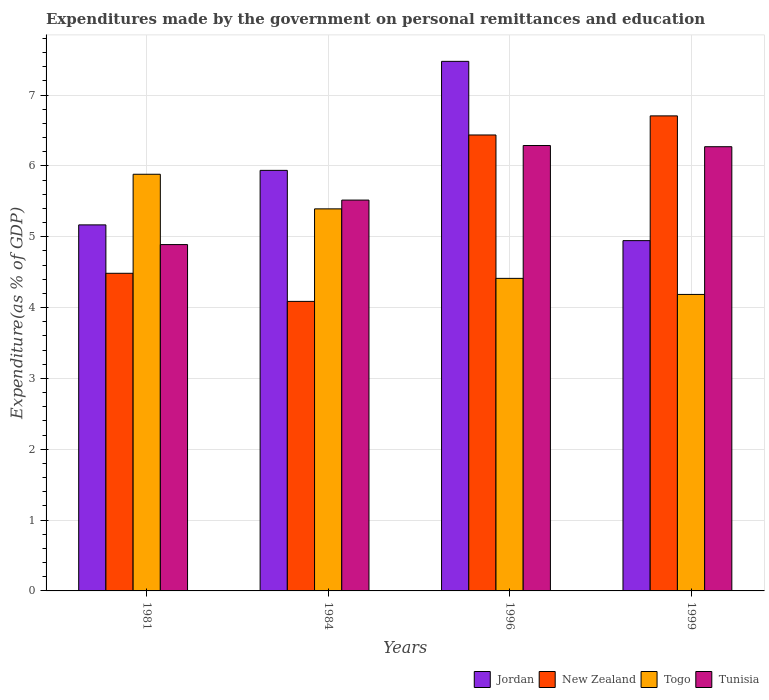How many different coloured bars are there?
Offer a very short reply. 4. How many groups of bars are there?
Make the answer very short. 4. Are the number of bars per tick equal to the number of legend labels?
Ensure brevity in your answer.  Yes. Are the number of bars on each tick of the X-axis equal?
Offer a very short reply. Yes. How many bars are there on the 3rd tick from the left?
Ensure brevity in your answer.  4. How many bars are there on the 1st tick from the right?
Offer a very short reply. 4. What is the expenditures made by the government on personal remittances and education in Jordan in 1984?
Make the answer very short. 5.94. Across all years, what is the maximum expenditures made by the government on personal remittances and education in New Zealand?
Your answer should be very brief. 6.71. Across all years, what is the minimum expenditures made by the government on personal remittances and education in New Zealand?
Ensure brevity in your answer.  4.09. In which year was the expenditures made by the government on personal remittances and education in New Zealand maximum?
Your answer should be compact. 1999. In which year was the expenditures made by the government on personal remittances and education in Jordan minimum?
Offer a terse response. 1999. What is the total expenditures made by the government on personal remittances and education in Jordan in the graph?
Your answer should be very brief. 23.53. What is the difference between the expenditures made by the government on personal remittances and education in Jordan in 1981 and that in 1984?
Offer a terse response. -0.77. What is the difference between the expenditures made by the government on personal remittances and education in Jordan in 1981 and the expenditures made by the government on personal remittances and education in Togo in 1996?
Make the answer very short. 0.75. What is the average expenditures made by the government on personal remittances and education in Jordan per year?
Your response must be concise. 5.88. In the year 1984, what is the difference between the expenditures made by the government on personal remittances and education in Tunisia and expenditures made by the government on personal remittances and education in Jordan?
Provide a succinct answer. -0.42. In how many years, is the expenditures made by the government on personal remittances and education in Togo greater than 1.8 %?
Your response must be concise. 4. What is the ratio of the expenditures made by the government on personal remittances and education in Jordan in 1981 to that in 1996?
Give a very brief answer. 0.69. Is the difference between the expenditures made by the government on personal remittances and education in Tunisia in 1981 and 1996 greater than the difference between the expenditures made by the government on personal remittances and education in Jordan in 1981 and 1996?
Give a very brief answer. Yes. What is the difference between the highest and the second highest expenditures made by the government on personal remittances and education in New Zealand?
Offer a terse response. 0.27. What is the difference between the highest and the lowest expenditures made by the government on personal remittances and education in New Zealand?
Offer a very short reply. 2.62. In how many years, is the expenditures made by the government on personal remittances and education in New Zealand greater than the average expenditures made by the government on personal remittances and education in New Zealand taken over all years?
Your answer should be compact. 2. What does the 1st bar from the left in 1984 represents?
Give a very brief answer. Jordan. What does the 4th bar from the right in 1984 represents?
Make the answer very short. Jordan. What is the difference between two consecutive major ticks on the Y-axis?
Make the answer very short. 1. Does the graph contain any zero values?
Your answer should be very brief. No. Does the graph contain grids?
Provide a succinct answer. Yes. How many legend labels are there?
Offer a very short reply. 4. What is the title of the graph?
Offer a very short reply. Expenditures made by the government on personal remittances and education. Does "OECD members" appear as one of the legend labels in the graph?
Your answer should be very brief. No. What is the label or title of the X-axis?
Provide a short and direct response. Years. What is the label or title of the Y-axis?
Provide a succinct answer. Expenditure(as % of GDP). What is the Expenditure(as % of GDP) in Jordan in 1981?
Your response must be concise. 5.17. What is the Expenditure(as % of GDP) in New Zealand in 1981?
Your response must be concise. 4.48. What is the Expenditure(as % of GDP) of Togo in 1981?
Offer a terse response. 5.88. What is the Expenditure(as % of GDP) in Tunisia in 1981?
Make the answer very short. 4.89. What is the Expenditure(as % of GDP) in Jordan in 1984?
Your answer should be compact. 5.94. What is the Expenditure(as % of GDP) of New Zealand in 1984?
Give a very brief answer. 4.09. What is the Expenditure(as % of GDP) of Togo in 1984?
Ensure brevity in your answer.  5.39. What is the Expenditure(as % of GDP) of Tunisia in 1984?
Offer a terse response. 5.52. What is the Expenditure(as % of GDP) of Jordan in 1996?
Your answer should be very brief. 7.48. What is the Expenditure(as % of GDP) of New Zealand in 1996?
Offer a terse response. 6.44. What is the Expenditure(as % of GDP) in Togo in 1996?
Offer a very short reply. 4.41. What is the Expenditure(as % of GDP) of Tunisia in 1996?
Offer a terse response. 6.29. What is the Expenditure(as % of GDP) of Jordan in 1999?
Your response must be concise. 4.95. What is the Expenditure(as % of GDP) of New Zealand in 1999?
Keep it short and to the point. 6.71. What is the Expenditure(as % of GDP) of Togo in 1999?
Keep it short and to the point. 4.19. What is the Expenditure(as % of GDP) in Tunisia in 1999?
Keep it short and to the point. 6.27. Across all years, what is the maximum Expenditure(as % of GDP) in Jordan?
Provide a short and direct response. 7.48. Across all years, what is the maximum Expenditure(as % of GDP) in New Zealand?
Ensure brevity in your answer.  6.71. Across all years, what is the maximum Expenditure(as % of GDP) of Togo?
Make the answer very short. 5.88. Across all years, what is the maximum Expenditure(as % of GDP) in Tunisia?
Provide a succinct answer. 6.29. Across all years, what is the minimum Expenditure(as % of GDP) in Jordan?
Provide a short and direct response. 4.95. Across all years, what is the minimum Expenditure(as % of GDP) of New Zealand?
Your answer should be very brief. 4.09. Across all years, what is the minimum Expenditure(as % of GDP) in Togo?
Offer a very short reply. 4.19. Across all years, what is the minimum Expenditure(as % of GDP) in Tunisia?
Offer a very short reply. 4.89. What is the total Expenditure(as % of GDP) in Jordan in the graph?
Keep it short and to the point. 23.53. What is the total Expenditure(as % of GDP) of New Zealand in the graph?
Your response must be concise. 21.71. What is the total Expenditure(as % of GDP) of Togo in the graph?
Make the answer very short. 19.87. What is the total Expenditure(as % of GDP) in Tunisia in the graph?
Provide a succinct answer. 22.97. What is the difference between the Expenditure(as % of GDP) in Jordan in 1981 and that in 1984?
Offer a very short reply. -0.77. What is the difference between the Expenditure(as % of GDP) of New Zealand in 1981 and that in 1984?
Your response must be concise. 0.4. What is the difference between the Expenditure(as % of GDP) in Togo in 1981 and that in 1984?
Your response must be concise. 0.49. What is the difference between the Expenditure(as % of GDP) of Tunisia in 1981 and that in 1984?
Provide a succinct answer. -0.63. What is the difference between the Expenditure(as % of GDP) in Jordan in 1981 and that in 1996?
Make the answer very short. -2.31. What is the difference between the Expenditure(as % of GDP) in New Zealand in 1981 and that in 1996?
Your response must be concise. -1.95. What is the difference between the Expenditure(as % of GDP) in Togo in 1981 and that in 1996?
Ensure brevity in your answer.  1.47. What is the difference between the Expenditure(as % of GDP) of Tunisia in 1981 and that in 1996?
Provide a succinct answer. -1.4. What is the difference between the Expenditure(as % of GDP) in Jordan in 1981 and that in 1999?
Make the answer very short. 0.22. What is the difference between the Expenditure(as % of GDP) of New Zealand in 1981 and that in 1999?
Provide a succinct answer. -2.22. What is the difference between the Expenditure(as % of GDP) in Togo in 1981 and that in 1999?
Ensure brevity in your answer.  1.7. What is the difference between the Expenditure(as % of GDP) in Tunisia in 1981 and that in 1999?
Your response must be concise. -1.38. What is the difference between the Expenditure(as % of GDP) in Jordan in 1984 and that in 1996?
Offer a terse response. -1.54. What is the difference between the Expenditure(as % of GDP) in New Zealand in 1984 and that in 1996?
Offer a terse response. -2.35. What is the difference between the Expenditure(as % of GDP) of Togo in 1984 and that in 1996?
Provide a short and direct response. 0.98. What is the difference between the Expenditure(as % of GDP) in Tunisia in 1984 and that in 1996?
Give a very brief answer. -0.77. What is the difference between the Expenditure(as % of GDP) of New Zealand in 1984 and that in 1999?
Offer a terse response. -2.62. What is the difference between the Expenditure(as % of GDP) of Togo in 1984 and that in 1999?
Your answer should be compact. 1.21. What is the difference between the Expenditure(as % of GDP) of Tunisia in 1984 and that in 1999?
Ensure brevity in your answer.  -0.75. What is the difference between the Expenditure(as % of GDP) of Jordan in 1996 and that in 1999?
Make the answer very short. 2.53. What is the difference between the Expenditure(as % of GDP) in New Zealand in 1996 and that in 1999?
Your answer should be very brief. -0.27. What is the difference between the Expenditure(as % of GDP) in Togo in 1996 and that in 1999?
Give a very brief answer. 0.23. What is the difference between the Expenditure(as % of GDP) in Tunisia in 1996 and that in 1999?
Offer a very short reply. 0.02. What is the difference between the Expenditure(as % of GDP) in Jordan in 1981 and the Expenditure(as % of GDP) in Togo in 1984?
Your response must be concise. -0.23. What is the difference between the Expenditure(as % of GDP) in Jordan in 1981 and the Expenditure(as % of GDP) in Tunisia in 1984?
Ensure brevity in your answer.  -0.35. What is the difference between the Expenditure(as % of GDP) in New Zealand in 1981 and the Expenditure(as % of GDP) in Togo in 1984?
Ensure brevity in your answer.  -0.91. What is the difference between the Expenditure(as % of GDP) in New Zealand in 1981 and the Expenditure(as % of GDP) in Tunisia in 1984?
Offer a very short reply. -1.03. What is the difference between the Expenditure(as % of GDP) of Togo in 1981 and the Expenditure(as % of GDP) of Tunisia in 1984?
Provide a succinct answer. 0.36. What is the difference between the Expenditure(as % of GDP) of Jordan in 1981 and the Expenditure(as % of GDP) of New Zealand in 1996?
Provide a short and direct response. -1.27. What is the difference between the Expenditure(as % of GDP) of Jordan in 1981 and the Expenditure(as % of GDP) of Togo in 1996?
Make the answer very short. 0.75. What is the difference between the Expenditure(as % of GDP) in Jordan in 1981 and the Expenditure(as % of GDP) in Tunisia in 1996?
Make the answer very short. -1.12. What is the difference between the Expenditure(as % of GDP) in New Zealand in 1981 and the Expenditure(as % of GDP) in Togo in 1996?
Your answer should be compact. 0.07. What is the difference between the Expenditure(as % of GDP) in New Zealand in 1981 and the Expenditure(as % of GDP) in Tunisia in 1996?
Your answer should be compact. -1.8. What is the difference between the Expenditure(as % of GDP) in Togo in 1981 and the Expenditure(as % of GDP) in Tunisia in 1996?
Ensure brevity in your answer.  -0.41. What is the difference between the Expenditure(as % of GDP) of Jordan in 1981 and the Expenditure(as % of GDP) of New Zealand in 1999?
Provide a succinct answer. -1.54. What is the difference between the Expenditure(as % of GDP) in Jordan in 1981 and the Expenditure(as % of GDP) in Togo in 1999?
Your answer should be very brief. 0.98. What is the difference between the Expenditure(as % of GDP) of Jordan in 1981 and the Expenditure(as % of GDP) of Tunisia in 1999?
Keep it short and to the point. -1.1. What is the difference between the Expenditure(as % of GDP) of New Zealand in 1981 and the Expenditure(as % of GDP) of Togo in 1999?
Your answer should be compact. 0.3. What is the difference between the Expenditure(as % of GDP) in New Zealand in 1981 and the Expenditure(as % of GDP) in Tunisia in 1999?
Your answer should be compact. -1.79. What is the difference between the Expenditure(as % of GDP) of Togo in 1981 and the Expenditure(as % of GDP) of Tunisia in 1999?
Offer a terse response. -0.39. What is the difference between the Expenditure(as % of GDP) in Jordan in 1984 and the Expenditure(as % of GDP) in New Zealand in 1996?
Keep it short and to the point. -0.5. What is the difference between the Expenditure(as % of GDP) of Jordan in 1984 and the Expenditure(as % of GDP) of Togo in 1996?
Provide a short and direct response. 1.52. What is the difference between the Expenditure(as % of GDP) of Jordan in 1984 and the Expenditure(as % of GDP) of Tunisia in 1996?
Make the answer very short. -0.35. What is the difference between the Expenditure(as % of GDP) in New Zealand in 1984 and the Expenditure(as % of GDP) in Togo in 1996?
Ensure brevity in your answer.  -0.33. What is the difference between the Expenditure(as % of GDP) of New Zealand in 1984 and the Expenditure(as % of GDP) of Tunisia in 1996?
Your answer should be very brief. -2.2. What is the difference between the Expenditure(as % of GDP) in Togo in 1984 and the Expenditure(as % of GDP) in Tunisia in 1996?
Keep it short and to the point. -0.89. What is the difference between the Expenditure(as % of GDP) of Jordan in 1984 and the Expenditure(as % of GDP) of New Zealand in 1999?
Provide a succinct answer. -0.77. What is the difference between the Expenditure(as % of GDP) of Jordan in 1984 and the Expenditure(as % of GDP) of Togo in 1999?
Provide a succinct answer. 1.75. What is the difference between the Expenditure(as % of GDP) in Jordan in 1984 and the Expenditure(as % of GDP) in Tunisia in 1999?
Offer a terse response. -0.33. What is the difference between the Expenditure(as % of GDP) in New Zealand in 1984 and the Expenditure(as % of GDP) in Togo in 1999?
Your answer should be compact. -0.1. What is the difference between the Expenditure(as % of GDP) in New Zealand in 1984 and the Expenditure(as % of GDP) in Tunisia in 1999?
Give a very brief answer. -2.18. What is the difference between the Expenditure(as % of GDP) in Togo in 1984 and the Expenditure(as % of GDP) in Tunisia in 1999?
Your answer should be very brief. -0.88. What is the difference between the Expenditure(as % of GDP) of Jordan in 1996 and the Expenditure(as % of GDP) of New Zealand in 1999?
Give a very brief answer. 0.77. What is the difference between the Expenditure(as % of GDP) of Jordan in 1996 and the Expenditure(as % of GDP) of Togo in 1999?
Your response must be concise. 3.29. What is the difference between the Expenditure(as % of GDP) in Jordan in 1996 and the Expenditure(as % of GDP) in Tunisia in 1999?
Give a very brief answer. 1.21. What is the difference between the Expenditure(as % of GDP) of New Zealand in 1996 and the Expenditure(as % of GDP) of Togo in 1999?
Make the answer very short. 2.25. What is the difference between the Expenditure(as % of GDP) in New Zealand in 1996 and the Expenditure(as % of GDP) in Tunisia in 1999?
Provide a short and direct response. 0.17. What is the difference between the Expenditure(as % of GDP) in Togo in 1996 and the Expenditure(as % of GDP) in Tunisia in 1999?
Keep it short and to the point. -1.86. What is the average Expenditure(as % of GDP) in Jordan per year?
Give a very brief answer. 5.88. What is the average Expenditure(as % of GDP) in New Zealand per year?
Offer a terse response. 5.43. What is the average Expenditure(as % of GDP) of Togo per year?
Make the answer very short. 4.97. What is the average Expenditure(as % of GDP) in Tunisia per year?
Your response must be concise. 5.74. In the year 1981, what is the difference between the Expenditure(as % of GDP) in Jordan and Expenditure(as % of GDP) in New Zealand?
Offer a terse response. 0.68. In the year 1981, what is the difference between the Expenditure(as % of GDP) of Jordan and Expenditure(as % of GDP) of Togo?
Ensure brevity in your answer.  -0.71. In the year 1981, what is the difference between the Expenditure(as % of GDP) of Jordan and Expenditure(as % of GDP) of Tunisia?
Give a very brief answer. 0.28. In the year 1981, what is the difference between the Expenditure(as % of GDP) in New Zealand and Expenditure(as % of GDP) in Togo?
Provide a succinct answer. -1.4. In the year 1981, what is the difference between the Expenditure(as % of GDP) of New Zealand and Expenditure(as % of GDP) of Tunisia?
Your response must be concise. -0.41. In the year 1984, what is the difference between the Expenditure(as % of GDP) in Jordan and Expenditure(as % of GDP) in New Zealand?
Give a very brief answer. 1.85. In the year 1984, what is the difference between the Expenditure(as % of GDP) of Jordan and Expenditure(as % of GDP) of Togo?
Ensure brevity in your answer.  0.54. In the year 1984, what is the difference between the Expenditure(as % of GDP) of Jordan and Expenditure(as % of GDP) of Tunisia?
Your answer should be very brief. 0.42. In the year 1984, what is the difference between the Expenditure(as % of GDP) of New Zealand and Expenditure(as % of GDP) of Togo?
Keep it short and to the point. -1.31. In the year 1984, what is the difference between the Expenditure(as % of GDP) of New Zealand and Expenditure(as % of GDP) of Tunisia?
Make the answer very short. -1.43. In the year 1984, what is the difference between the Expenditure(as % of GDP) of Togo and Expenditure(as % of GDP) of Tunisia?
Offer a very short reply. -0.12. In the year 1996, what is the difference between the Expenditure(as % of GDP) of Jordan and Expenditure(as % of GDP) of New Zealand?
Your answer should be compact. 1.04. In the year 1996, what is the difference between the Expenditure(as % of GDP) of Jordan and Expenditure(as % of GDP) of Togo?
Your response must be concise. 3.06. In the year 1996, what is the difference between the Expenditure(as % of GDP) of Jordan and Expenditure(as % of GDP) of Tunisia?
Make the answer very short. 1.19. In the year 1996, what is the difference between the Expenditure(as % of GDP) of New Zealand and Expenditure(as % of GDP) of Togo?
Offer a terse response. 2.02. In the year 1996, what is the difference between the Expenditure(as % of GDP) of New Zealand and Expenditure(as % of GDP) of Tunisia?
Make the answer very short. 0.15. In the year 1996, what is the difference between the Expenditure(as % of GDP) of Togo and Expenditure(as % of GDP) of Tunisia?
Offer a very short reply. -1.88. In the year 1999, what is the difference between the Expenditure(as % of GDP) in Jordan and Expenditure(as % of GDP) in New Zealand?
Your response must be concise. -1.76. In the year 1999, what is the difference between the Expenditure(as % of GDP) in Jordan and Expenditure(as % of GDP) in Togo?
Your response must be concise. 0.76. In the year 1999, what is the difference between the Expenditure(as % of GDP) in Jordan and Expenditure(as % of GDP) in Tunisia?
Provide a succinct answer. -1.33. In the year 1999, what is the difference between the Expenditure(as % of GDP) of New Zealand and Expenditure(as % of GDP) of Togo?
Make the answer very short. 2.52. In the year 1999, what is the difference between the Expenditure(as % of GDP) in New Zealand and Expenditure(as % of GDP) in Tunisia?
Offer a very short reply. 0.44. In the year 1999, what is the difference between the Expenditure(as % of GDP) in Togo and Expenditure(as % of GDP) in Tunisia?
Offer a terse response. -2.09. What is the ratio of the Expenditure(as % of GDP) of Jordan in 1981 to that in 1984?
Make the answer very short. 0.87. What is the ratio of the Expenditure(as % of GDP) of New Zealand in 1981 to that in 1984?
Offer a terse response. 1.1. What is the ratio of the Expenditure(as % of GDP) of Togo in 1981 to that in 1984?
Provide a short and direct response. 1.09. What is the ratio of the Expenditure(as % of GDP) in Tunisia in 1981 to that in 1984?
Offer a very short reply. 0.89. What is the ratio of the Expenditure(as % of GDP) in Jordan in 1981 to that in 1996?
Provide a succinct answer. 0.69. What is the ratio of the Expenditure(as % of GDP) of New Zealand in 1981 to that in 1996?
Your answer should be compact. 0.7. What is the ratio of the Expenditure(as % of GDP) in Togo in 1981 to that in 1996?
Ensure brevity in your answer.  1.33. What is the ratio of the Expenditure(as % of GDP) of Tunisia in 1981 to that in 1996?
Give a very brief answer. 0.78. What is the ratio of the Expenditure(as % of GDP) in Jordan in 1981 to that in 1999?
Keep it short and to the point. 1.04. What is the ratio of the Expenditure(as % of GDP) of New Zealand in 1981 to that in 1999?
Offer a very short reply. 0.67. What is the ratio of the Expenditure(as % of GDP) of Togo in 1981 to that in 1999?
Your response must be concise. 1.41. What is the ratio of the Expenditure(as % of GDP) of Tunisia in 1981 to that in 1999?
Your answer should be very brief. 0.78. What is the ratio of the Expenditure(as % of GDP) of Jordan in 1984 to that in 1996?
Keep it short and to the point. 0.79. What is the ratio of the Expenditure(as % of GDP) in New Zealand in 1984 to that in 1996?
Keep it short and to the point. 0.64. What is the ratio of the Expenditure(as % of GDP) of Togo in 1984 to that in 1996?
Ensure brevity in your answer.  1.22. What is the ratio of the Expenditure(as % of GDP) in Tunisia in 1984 to that in 1996?
Your response must be concise. 0.88. What is the ratio of the Expenditure(as % of GDP) of Jordan in 1984 to that in 1999?
Provide a short and direct response. 1.2. What is the ratio of the Expenditure(as % of GDP) of New Zealand in 1984 to that in 1999?
Offer a terse response. 0.61. What is the ratio of the Expenditure(as % of GDP) in Togo in 1984 to that in 1999?
Offer a terse response. 1.29. What is the ratio of the Expenditure(as % of GDP) of Tunisia in 1984 to that in 1999?
Give a very brief answer. 0.88. What is the ratio of the Expenditure(as % of GDP) of Jordan in 1996 to that in 1999?
Offer a very short reply. 1.51. What is the ratio of the Expenditure(as % of GDP) of New Zealand in 1996 to that in 1999?
Offer a very short reply. 0.96. What is the ratio of the Expenditure(as % of GDP) in Togo in 1996 to that in 1999?
Your answer should be compact. 1.05. What is the difference between the highest and the second highest Expenditure(as % of GDP) in Jordan?
Make the answer very short. 1.54. What is the difference between the highest and the second highest Expenditure(as % of GDP) in New Zealand?
Offer a terse response. 0.27. What is the difference between the highest and the second highest Expenditure(as % of GDP) in Togo?
Offer a very short reply. 0.49. What is the difference between the highest and the second highest Expenditure(as % of GDP) of Tunisia?
Offer a very short reply. 0.02. What is the difference between the highest and the lowest Expenditure(as % of GDP) in Jordan?
Offer a very short reply. 2.53. What is the difference between the highest and the lowest Expenditure(as % of GDP) in New Zealand?
Give a very brief answer. 2.62. What is the difference between the highest and the lowest Expenditure(as % of GDP) of Togo?
Provide a succinct answer. 1.7. What is the difference between the highest and the lowest Expenditure(as % of GDP) in Tunisia?
Your answer should be very brief. 1.4. 